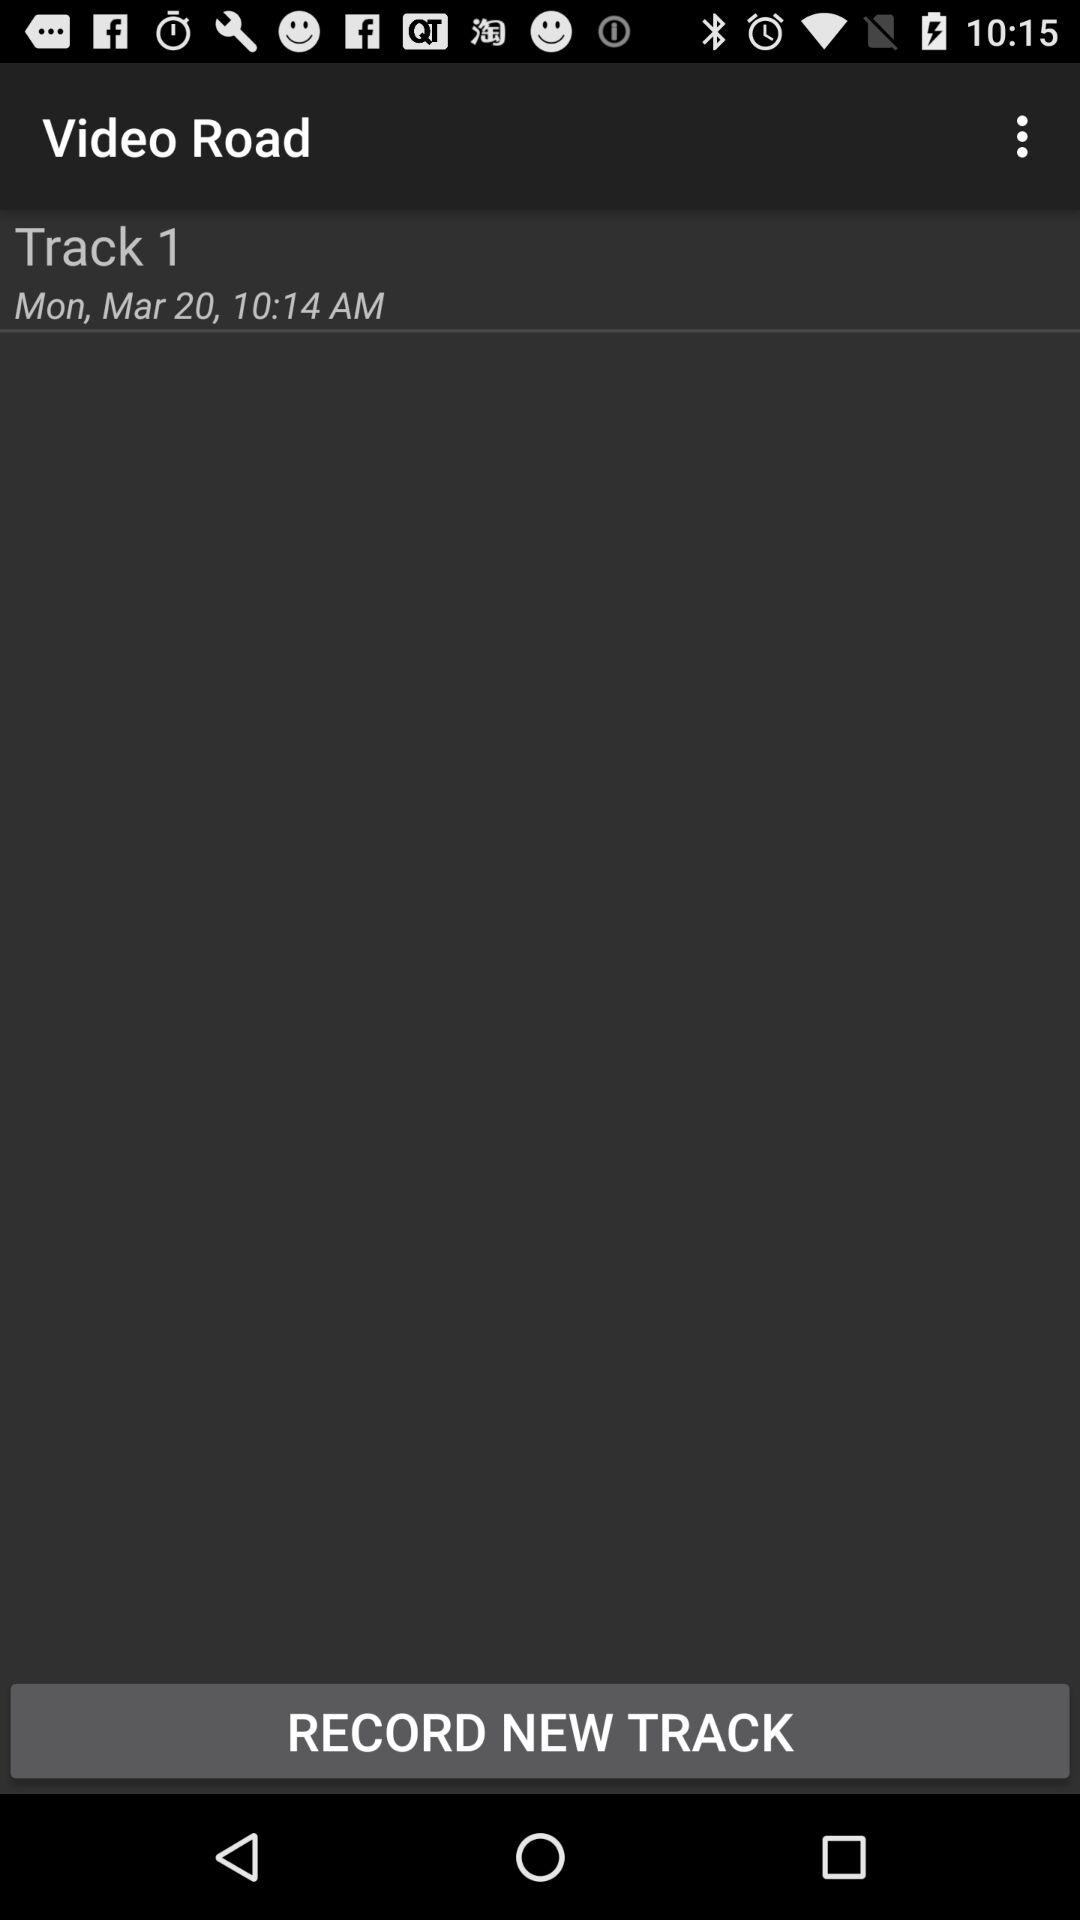Which day falls on March 20? The day is Monday. 